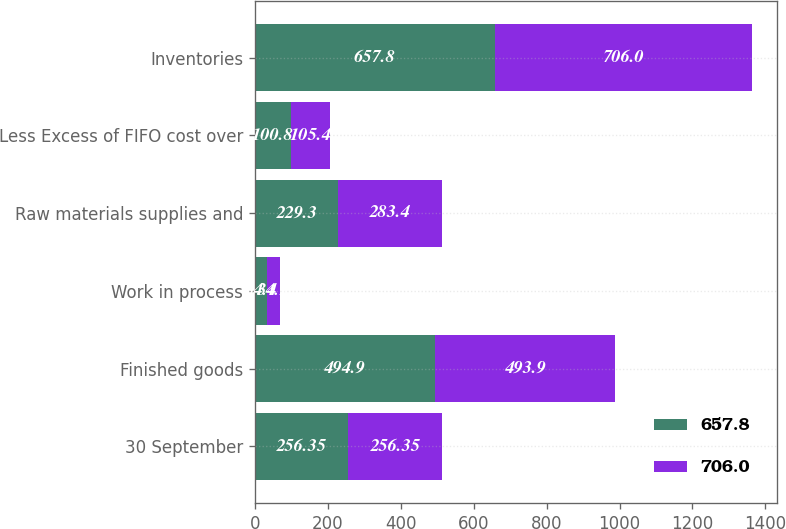<chart> <loc_0><loc_0><loc_500><loc_500><stacked_bar_chart><ecel><fcel>30 September<fcel>Finished goods<fcel>Work in process<fcel>Raw materials supplies and<fcel>Less Excess of FIFO cost over<fcel>Inventories<nl><fcel>657.8<fcel>256.35<fcel>494.9<fcel>34.4<fcel>229.3<fcel>100.8<fcel>657.8<nl><fcel>706<fcel>256.35<fcel>493.9<fcel>34.1<fcel>283.4<fcel>105.4<fcel>706<nl></chart> 